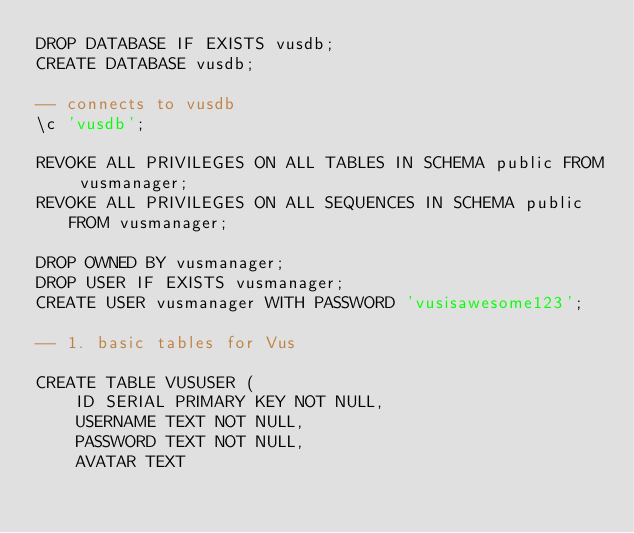<code> <loc_0><loc_0><loc_500><loc_500><_SQL_>DROP DATABASE IF EXISTS vusdb;
CREATE DATABASE vusdb;

-- connects to vusdb
\c 'vusdb';

REVOKE ALL PRIVILEGES ON ALL TABLES IN SCHEMA public FROM vusmanager;
REVOKE ALL PRIVILEGES ON ALL SEQUENCES IN SCHEMA public FROM vusmanager;

DROP OWNED BY vusmanager;
DROP USER IF EXISTS vusmanager;
CREATE USER vusmanager WITH PASSWORD 'vusisawesome123';

-- 1. basic tables for Vus

CREATE TABLE VUSUSER (
    ID SERIAL PRIMARY KEY NOT NULL,
    USERNAME TEXT NOT NULL,
    PASSWORD TEXT NOT NULL,
    AVATAR TEXT</code> 